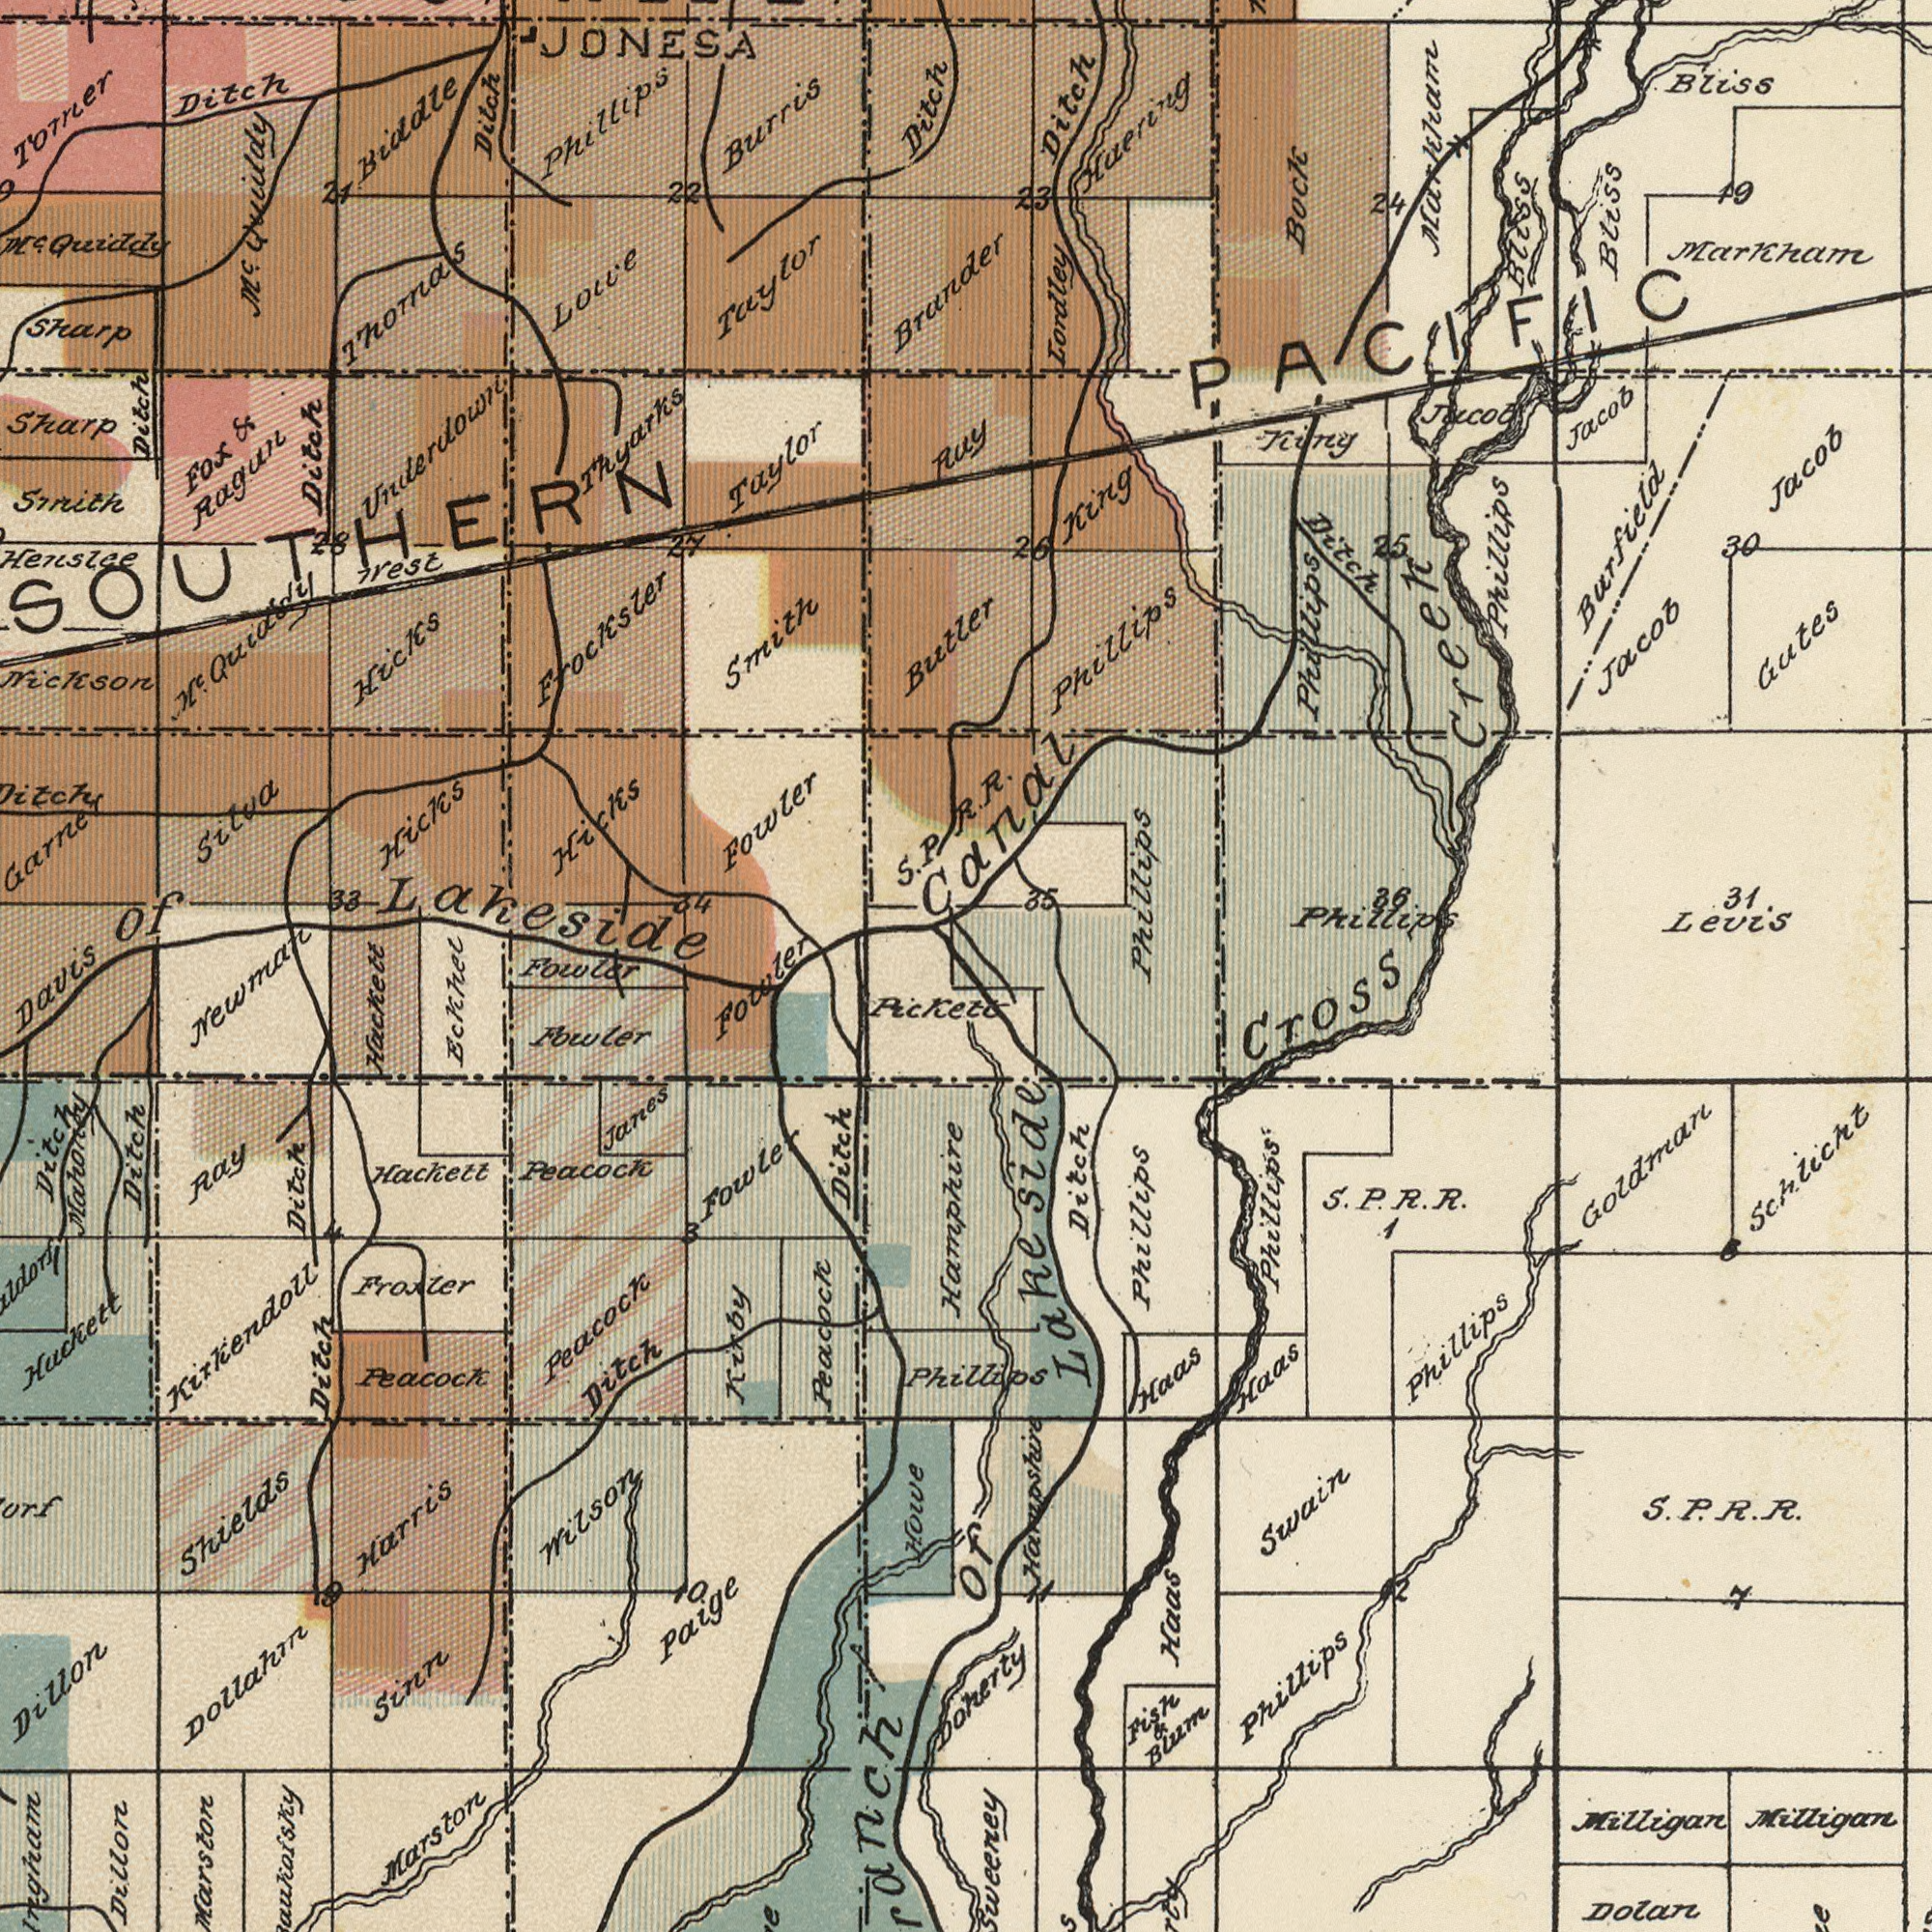What text is shown in the top-left quadrant? Henslae JONESA Fox & Ragun Smith Burris Underdown Sharp Fowler Taylor Frocksler Smith Ditch Lollie Phillips Taylor M<sup>c</sup>. Quiday Ditch Hicks Hicks Biddle Sharp Ditch Nickson M<sup>c</sup>. Quidgdy Ditch Torner West Garner Brander 33 22 Ditch Hicks Silva Butler M<sup>c</sup>. Quiddy Thomas Thyarks of Lakeside 27 21 34 9 28 Fowler SOUTHERN S. P. What text can you see in the top-right section? Canal Phillips Phillips Bliss Levis Phillips Lordley Markham Phillips King Gutes Jacob Jacob Jacob Jacob Ditch 23 24 36 Markham 19 Burfield King Bitch 30 Bliss 31 Bock 26 Bliss 35 Phillips Haering 25 Creek Ruy PACIFIC R. R. What text appears in the bottom-left area of the image? Shields Dollahm Dillon Dillon Harris Peacock Peacock Ditch Hackett Eckhel Ditch Fowler Marston Sinn Fowler Ray Ditch Ditch Paige Pickett Davis Holve Wilson Ditch Mahoney Peacock Ditch Froxler Hackett Janes Kirby Peacock 10 Huckett Fowler Kixkendoll 4 3 Newman 9 What text is visible in the lower-right corner? Cross Phillips of Lake Side. Hamphire Goldmar Phillips Dolan Milligan Schlicht Ditch Swain Phillips Haas S. P. R. R. Haas Haas Phillips Milligan 1 7 2 Phillips Donerty Fish & Blum Hampshire 11 6 S. P. R. R. 